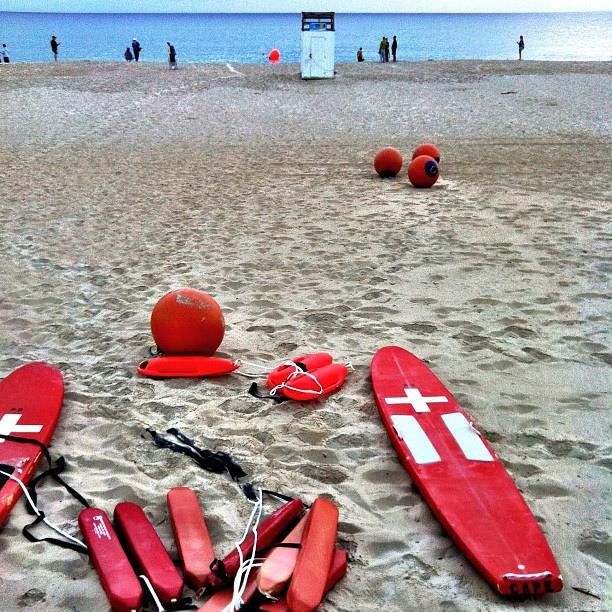Who does this gear on the beach belong to? lifeguard 